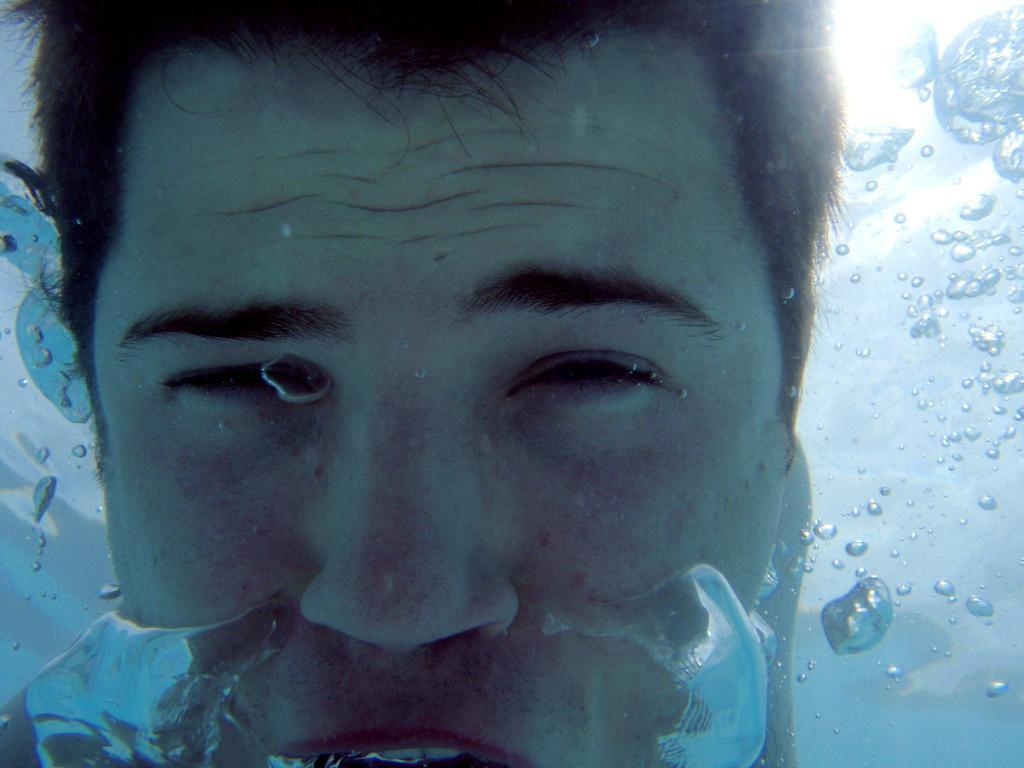Describe this image in one or two sentences. It is a zoomed in picture of a person in the water. 